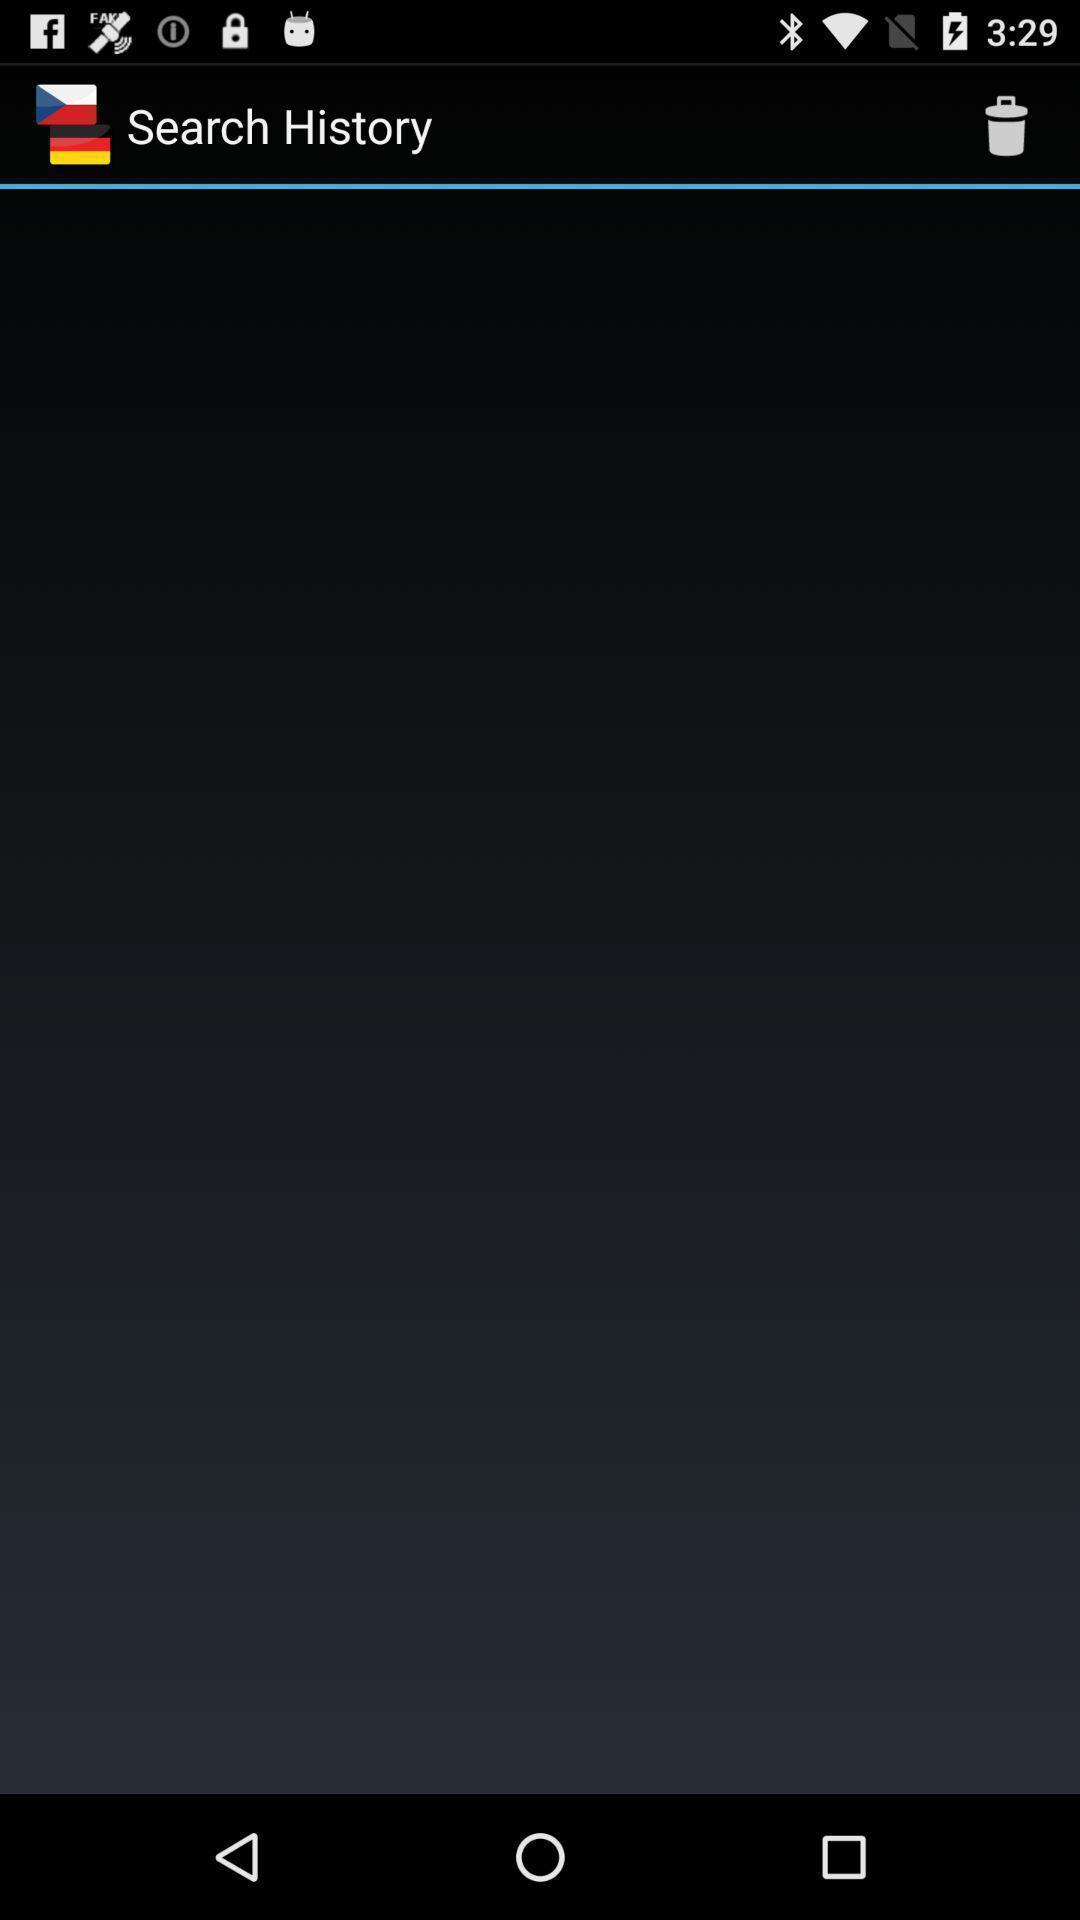Explain the elements present in this screenshot. Search history page of a dictionary app. 